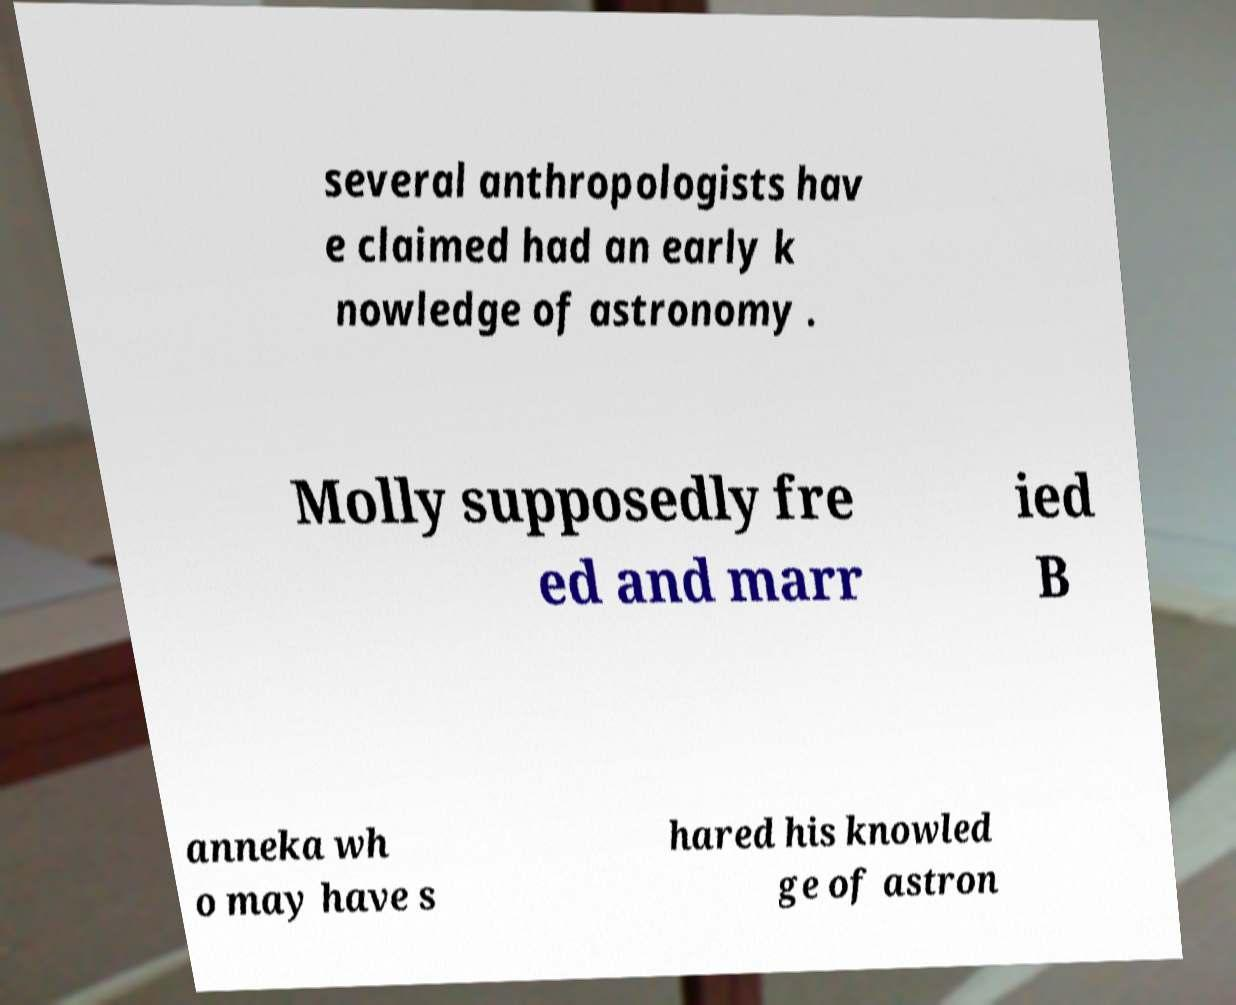There's text embedded in this image that I need extracted. Can you transcribe it verbatim? several anthropologists hav e claimed had an early k nowledge of astronomy . Molly supposedly fre ed and marr ied B anneka wh o may have s hared his knowled ge of astron 